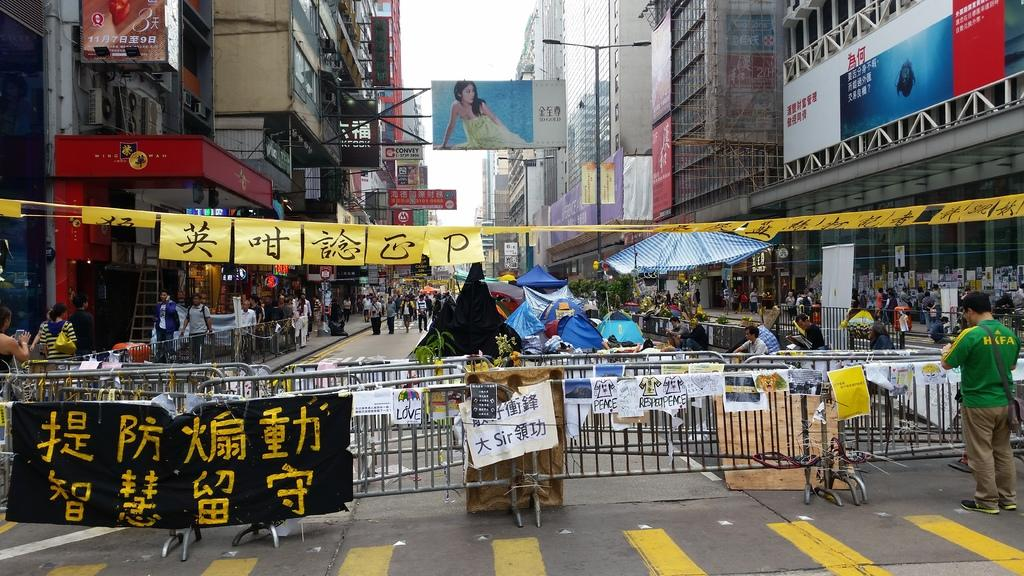<image>
Create a compact narrative representing the image presented. Many signs are on the railing, including one in English that says "respect" and "peace". 